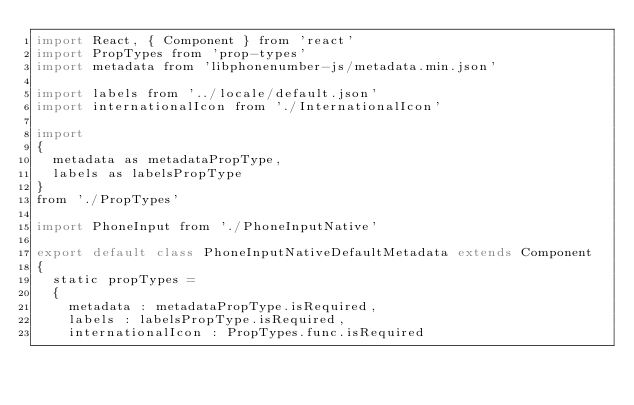Convert code to text. <code><loc_0><loc_0><loc_500><loc_500><_JavaScript_>import React, { Component } from 'react'
import PropTypes from 'prop-types'
import metadata from 'libphonenumber-js/metadata.min.json'

import labels from '../locale/default.json'
import internationalIcon from './InternationalIcon'

import
{
	metadata as metadataPropType,
	labels as labelsPropType
}
from './PropTypes'

import PhoneInput from './PhoneInputNative'

export default class PhoneInputNativeDefaultMetadata extends Component
{
	static propTypes =
	{
		metadata : metadataPropType.isRequired,
		labels : labelsPropType.isRequired,
		internationalIcon : PropTypes.func.isRequired</code> 